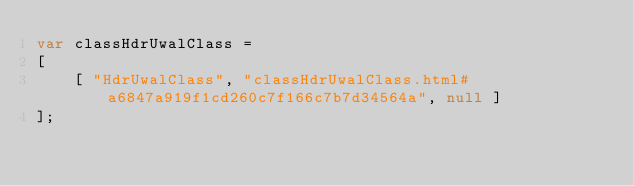<code> <loc_0><loc_0><loc_500><loc_500><_JavaScript_>var classHdrUwalClass =
[
    [ "HdrUwalClass", "classHdrUwalClass.html#a6847a919f1cd260c7f166c7b7d34564a", null ]
];</code> 